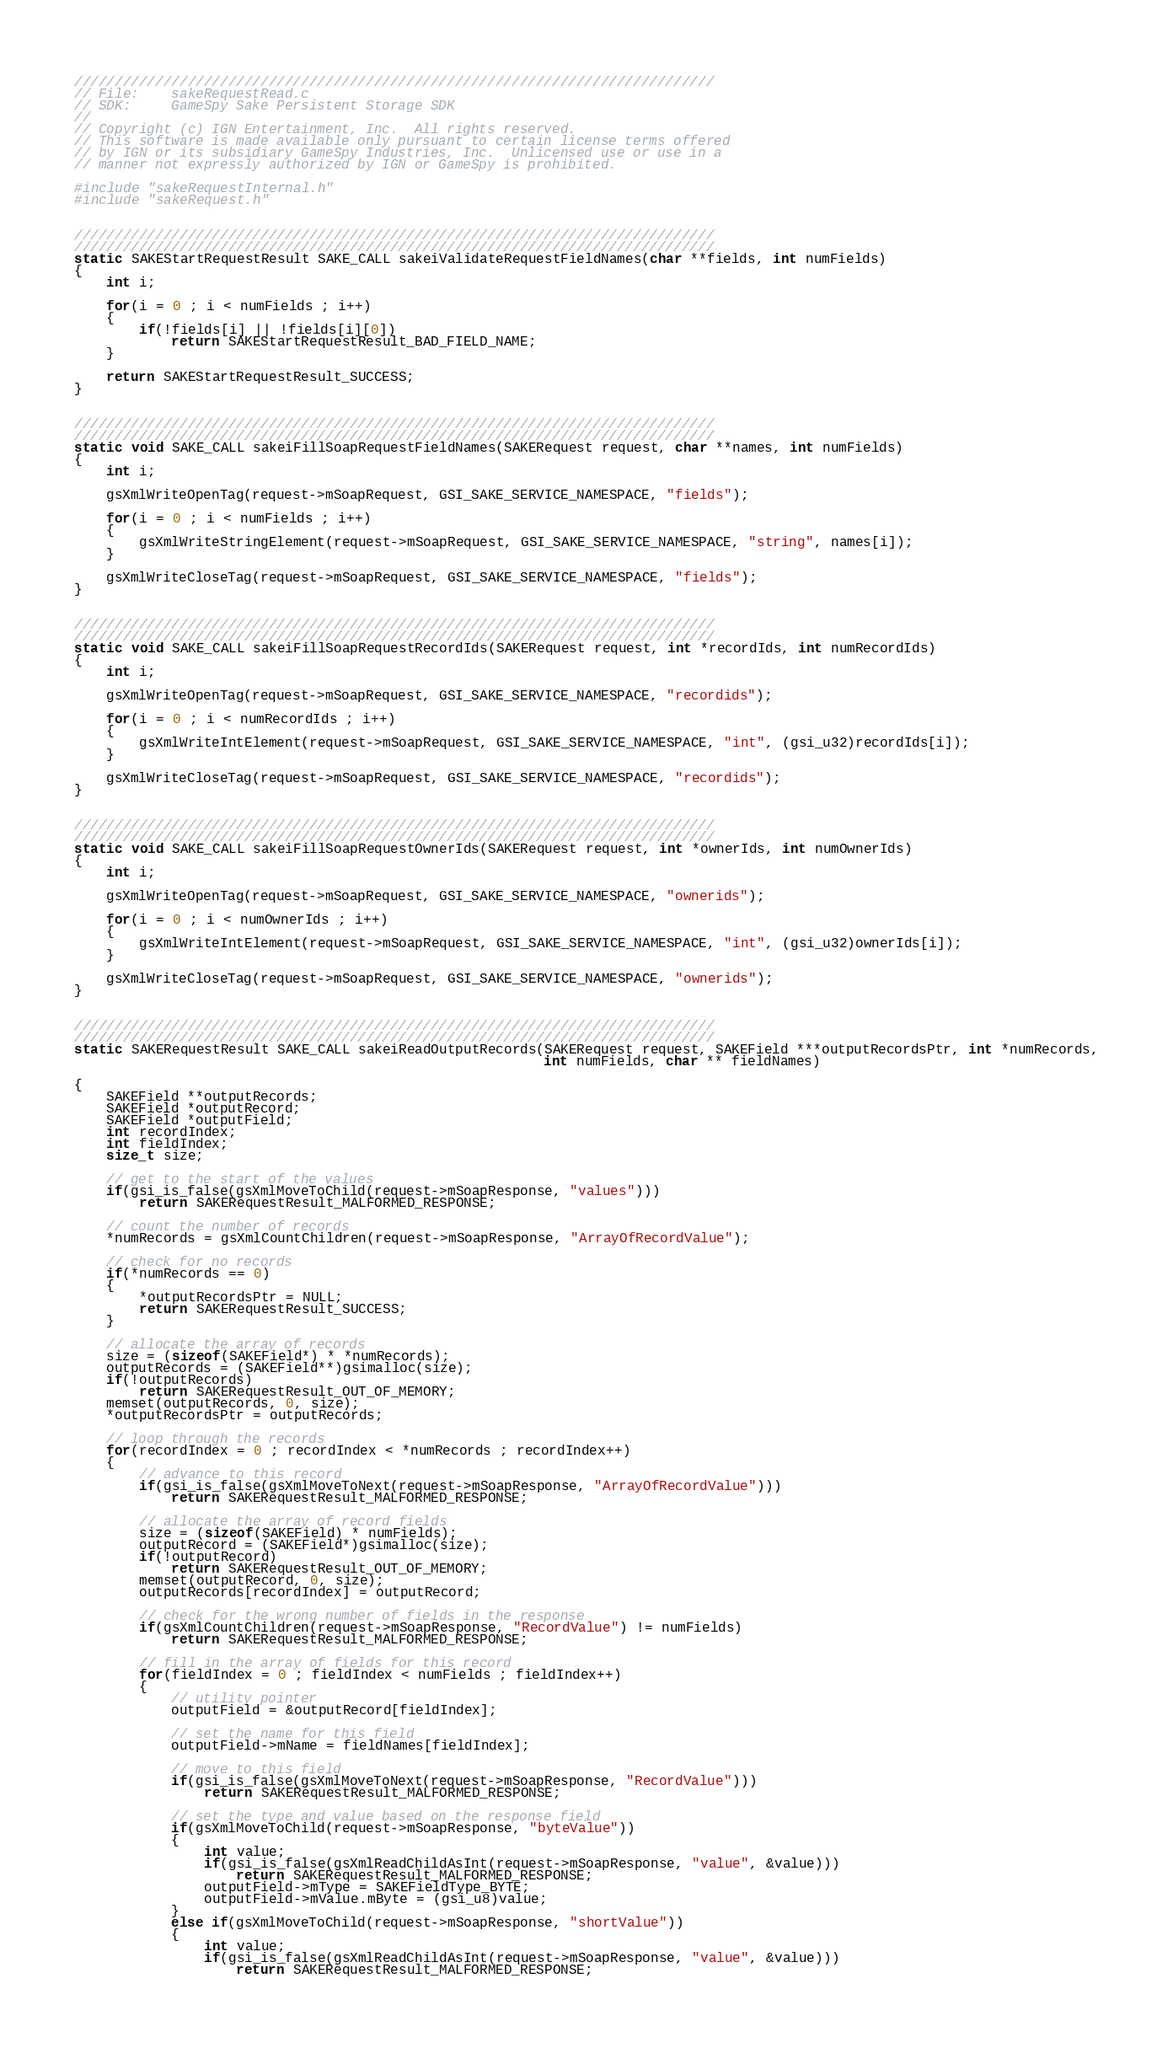<code> <loc_0><loc_0><loc_500><loc_500><_C_>///////////////////////////////////////////////////////////////////////////////
// File:	sakeRequestRead.c
// SDK:		GameSpy Sake Persistent Storage SDK
//
// Copyright (c) IGN Entertainment, Inc.  All rights reserved.  
// This software is made available only pursuant to certain license terms offered
// by IGN or its subsidiary GameSpy Industries, Inc.  Unlicensed use or use in a 
// manner not expressly authorized by IGN or GameSpy is prohibited.

#include "sakeRequestInternal.h"
#include "sakeRequest.h"


///////////////////////////////////////////////////////////////////////////////
///////////////////////////////////////////////////////////////////////////////
static SAKEStartRequestResult SAKE_CALL sakeiValidateRequestFieldNames(char **fields, int numFields)
{
	int i;

	for(i = 0 ; i < numFields ; i++)
	{
		if(!fields[i] || !fields[i][0])
			return SAKEStartRequestResult_BAD_FIELD_NAME;
	}

	return SAKEStartRequestResult_SUCCESS;
}


///////////////////////////////////////////////////////////////////////////////
///////////////////////////////////////////////////////////////////////////////
static void SAKE_CALL sakeiFillSoapRequestFieldNames(SAKERequest request, char **names, int numFields)
{
	int i;

	gsXmlWriteOpenTag(request->mSoapRequest, GSI_SAKE_SERVICE_NAMESPACE, "fields");

	for(i = 0 ; i < numFields ; i++)
	{
		gsXmlWriteStringElement(request->mSoapRequest, GSI_SAKE_SERVICE_NAMESPACE, "string", names[i]);
	}

	gsXmlWriteCloseTag(request->mSoapRequest, GSI_SAKE_SERVICE_NAMESPACE, "fields");
}


///////////////////////////////////////////////////////////////////////////////
///////////////////////////////////////////////////////////////////////////////
static void SAKE_CALL sakeiFillSoapRequestRecordIds(SAKERequest request, int *recordIds, int numRecordIds)
{
	int i;

	gsXmlWriteOpenTag(request->mSoapRequest, GSI_SAKE_SERVICE_NAMESPACE, "recordids");

	for(i = 0 ; i < numRecordIds ; i++)
	{
		gsXmlWriteIntElement(request->mSoapRequest, GSI_SAKE_SERVICE_NAMESPACE, "int", (gsi_u32)recordIds[i]);
	}

	gsXmlWriteCloseTag(request->mSoapRequest, GSI_SAKE_SERVICE_NAMESPACE, "recordids");
}


///////////////////////////////////////////////////////////////////////////////
///////////////////////////////////////////////////////////////////////////////
static void SAKE_CALL sakeiFillSoapRequestOwnerIds(SAKERequest request, int *ownerIds, int numOwnerIds)
{
	int i;

	gsXmlWriteOpenTag(request->mSoapRequest, GSI_SAKE_SERVICE_NAMESPACE, "ownerids");

	for(i = 0 ; i < numOwnerIds ; i++)
	{
		gsXmlWriteIntElement(request->mSoapRequest, GSI_SAKE_SERVICE_NAMESPACE, "int", (gsi_u32)ownerIds[i]);
	}

	gsXmlWriteCloseTag(request->mSoapRequest, GSI_SAKE_SERVICE_NAMESPACE, "ownerids");
}


///////////////////////////////////////////////////////////////////////////////
///////////////////////////////////////////////////////////////////////////////
static SAKERequestResult SAKE_CALL sakeiReadOutputRecords(SAKERequest request, SAKEField ***outputRecordsPtr, int *numRecords,
                                                          int numFields, char ** fieldNames)

{
	SAKEField **outputRecords;
	SAKEField *outputRecord;
	SAKEField *outputField;
	int recordIndex;
	int fieldIndex;
	size_t size;

	// get to the start of the values
	if(gsi_is_false(gsXmlMoveToChild(request->mSoapResponse, "values")))
		return SAKERequestResult_MALFORMED_RESPONSE;

	// count the number of records
	*numRecords = gsXmlCountChildren(request->mSoapResponse, "ArrayOfRecordValue");

	// check for no records
	if(*numRecords == 0)
	{
		*outputRecordsPtr = NULL;
		return SAKERequestResult_SUCCESS;
	}

	// allocate the array of records
	size = (sizeof(SAKEField*) * *numRecords);
	outputRecords = (SAKEField**)gsimalloc(size);
	if(!outputRecords)
		return SAKERequestResult_OUT_OF_MEMORY;
	memset(outputRecords, 0, size);
	*outputRecordsPtr = outputRecords;

	// loop through the records
	for(recordIndex = 0 ; recordIndex < *numRecords ; recordIndex++)
	{
		// advance to this record
		if(gsi_is_false(gsXmlMoveToNext(request->mSoapResponse, "ArrayOfRecordValue")))
			return SAKERequestResult_MALFORMED_RESPONSE;

		// allocate the array of record fields
		size = (sizeof(SAKEField) * numFields);
		outputRecord = (SAKEField*)gsimalloc(size);
		if(!outputRecord)
			return SAKERequestResult_OUT_OF_MEMORY;
		memset(outputRecord, 0, size);
		outputRecords[recordIndex] = outputRecord;

		// check for the wrong number of fields in the response
		if(gsXmlCountChildren(request->mSoapResponse, "RecordValue") != numFields)
			return SAKERequestResult_MALFORMED_RESPONSE;

		// fill in the array of fields for this record
		for(fieldIndex = 0 ; fieldIndex < numFields ; fieldIndex++)
		{
			// utility pointer
			outputField = &outputRecord[fieldIndex];

			// set the name for this field
			outputField->mName = fieldNames[fieldIndex];

			// move to this field
			if(gsi_is_false(gsXmlMoveToNext(request->mSoapResponse, "RecordValue")))
				return SAKERequestResult_MALFORMED_RESPONSE;

			// set the type and value based on the response field
			if(gsXmlMoveToChild(request->mSoapResponse, "byteValue"))
			{
				int value;
				if(gsi_is_false(gsXmlReadChildAsInt(request->mSoapResponse, "value", &value)))
					return SAKERequestResult_MALFORMED_RESPONSE;
				outputField->mType = SAKEFieldType_BYTE;
				outputField->mValue.mByte = (gsi_u8)value;
			}
			else if(gsXmlMoveToChild(request->mSoapResponse, "shortValue"))
			{
				int value;
				if(gsi_is_false(gsXmlReadChildAsInt(request->mSoapResponse, "value", &value)))
					return SAKERequestResult_MALFORMED_RESPONSE;</code> 